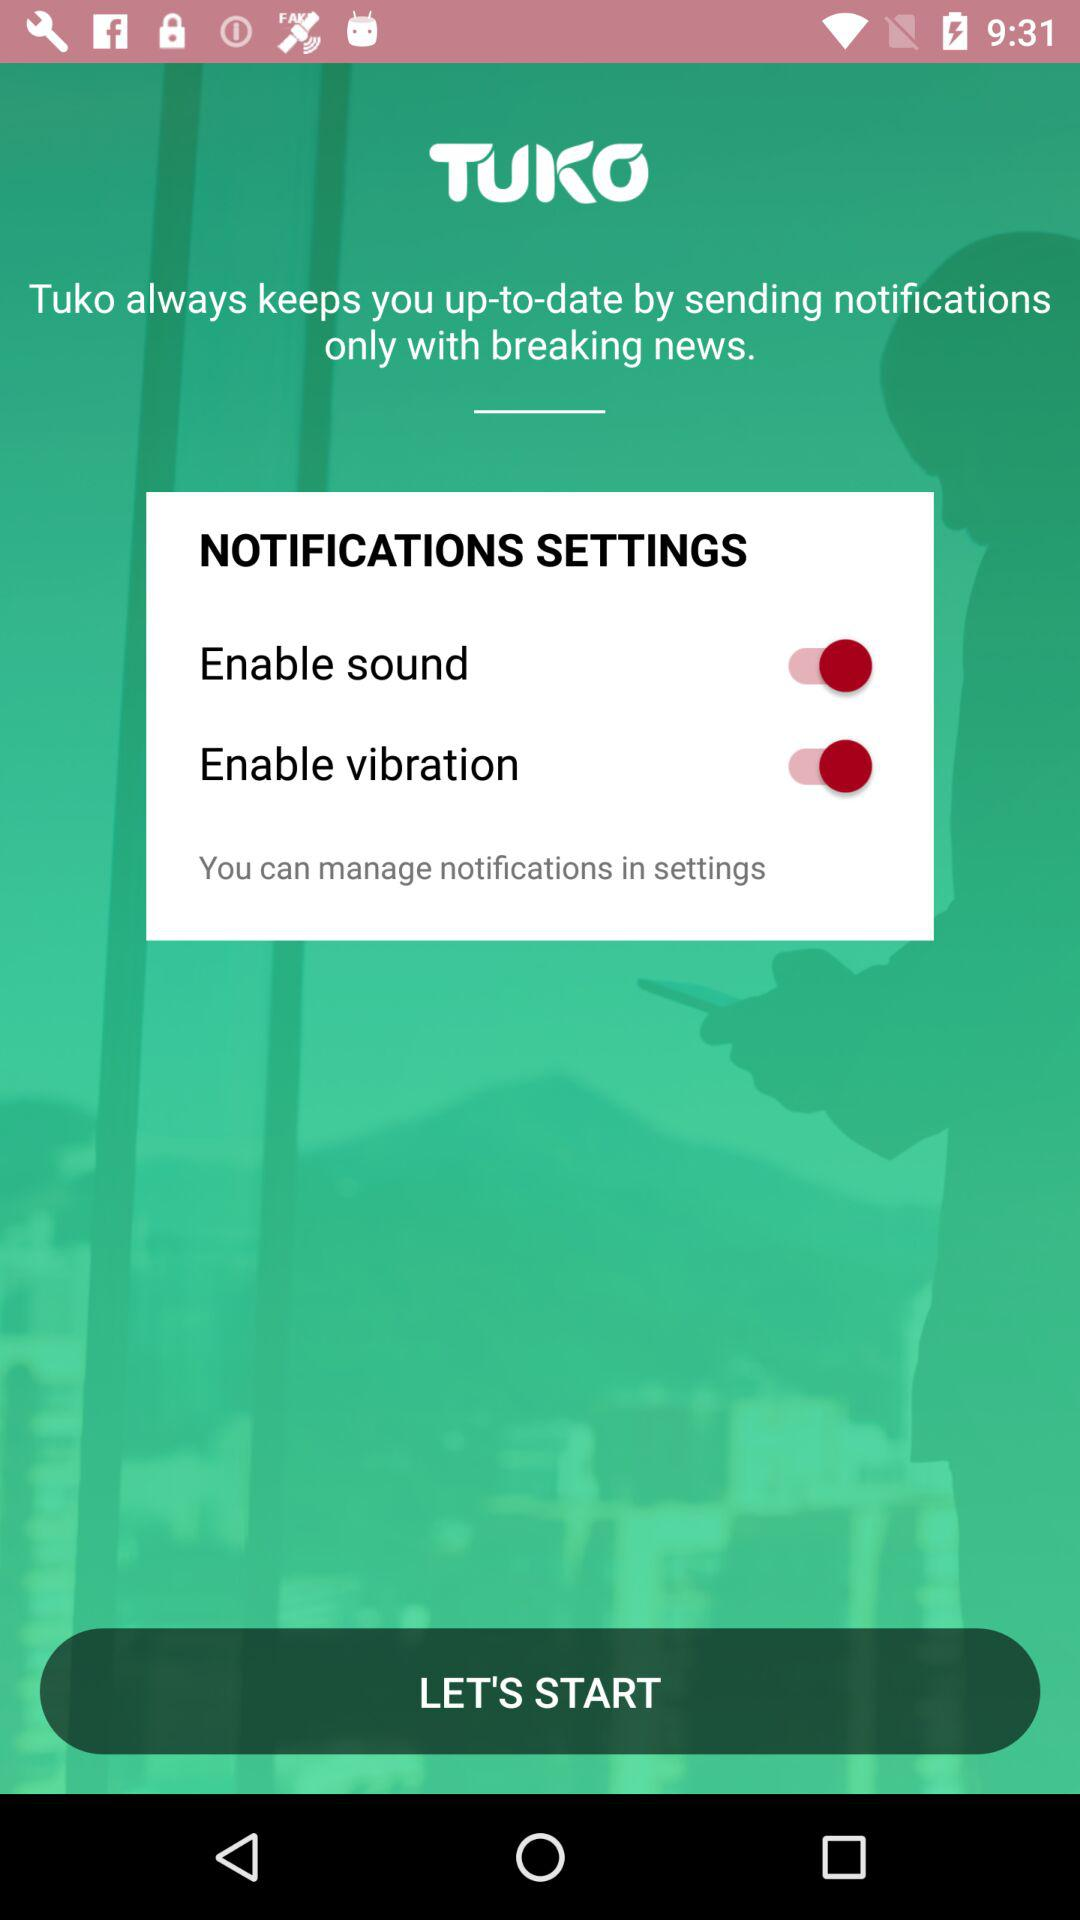What is the status of "Enable sound"? The status of "Enable sound" is "on". 